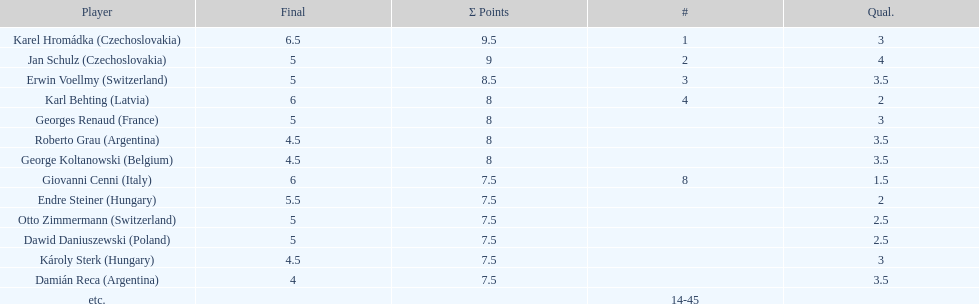How many players tied for 4th place? 4. 